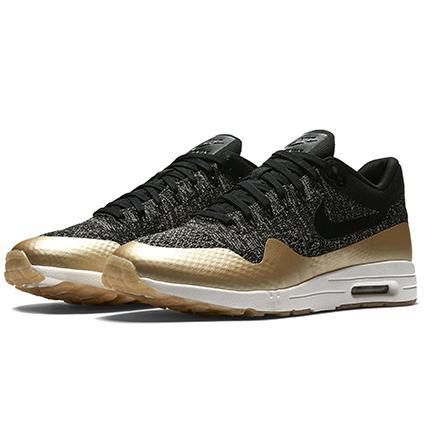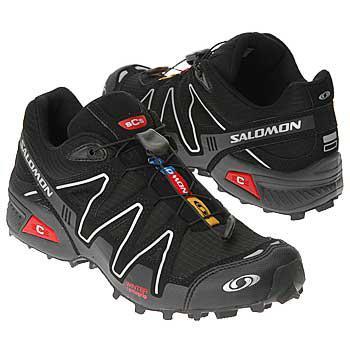The first image is the image on the left, the second image is the image on the right. Analyze the images presented: Is the assertion "In one image a shoe is flipped on its side." valid? Answer yes or no. No. The first image is the image on the left, the second image is the image on the right. Assess this claim about the two images: "All shoes feature hot pink and gray in their design, and all shoes have a curved boomerang-shaped logo on the side.". Correct or not? Answer yes or no. No. 